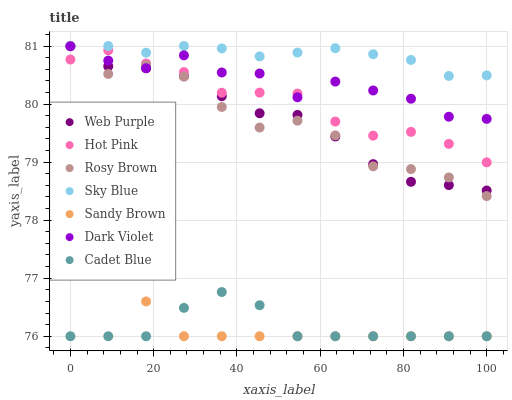Does Cadet Blue have the minimum area under the curve?
Answer yes or no. Yes. Does Sky Blue have the maximum area under the curve?
Answer yes or no. Yes. Does Hot Pink have the minimum area under the curve?
Answer yes or no. No. Does Hot Pink have the maximum area under the curve?
Answer yes or no. No. Is Sandy Brown the smoothest?
Answer yes or no. Yes. Is Rosy Brown the roughest?
Answer yes or no. Yes. Is Hot Pink the smoothest?
Answer yes or no. No. Is Hot Pink the roughest?
Answer yes or no. No. Does Cadet Blue have the lowest value?
Answer yes or no. Yes. Does Hot Pink have the lowest value?
Answer yes or no. No. Does Sky Blue have the highest value?
Answer yes or no. Yes. Does Hot Pink have the highest value?
Answer yes or no. No. Is Cadet Blue less than Web Purple?
Answer yes or no. Yes. Is Dark Violet greater than Cadet Blue?
Answer yes or no. Yes. Does Rosy Brown intersect Dark Violet?
Answer yes or no. Yes. Is Rosy Brown less than Dark Violet?
Answer yes or no. No. Is Rosy Brown greater than Dark Violet?
Answer yes or no. No. Does Cadet Blue intersect Web Purple?
Answer yes or no. No. 